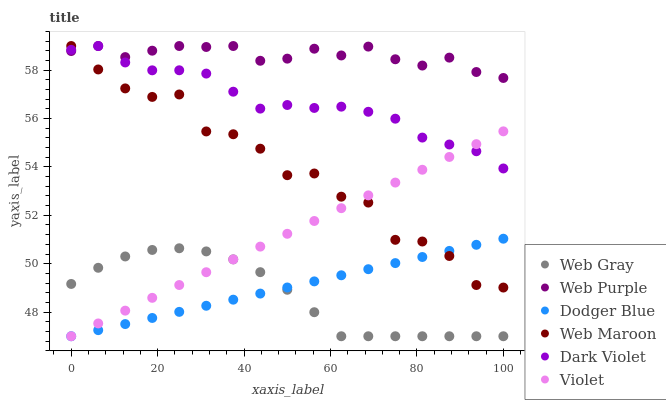Does Web Gray have the minimum area under the curve?
Answer yes or no. Yes. Does Web Purple have the maximum area under the curve?
Answer yes or no. Yes. Does Web Maroon have the minimum area under the curve?
Answer yes or no. No. Does Web Maroon have the maximum area under the curve?
Answer yes or no. No. Is Dodger Blue the smoothest?
Answer yes or no. Yes. Is Web Maroon the roughest?
Answer yes or no. Yes. Is Dark Violet the smoothest?
Answer yes or no. No. Is Dark Violet the roughest?
Answer yes or no. No. Does Web Gray have the lowest value?
Answer yes or no. Yes. Does Web Maroon have the lowest value?
Answer yes or no. No. Does Web Purple have the highest value?
Answer yes or no. Yes. Does Dodger Blue have the highest value?
Answer yes or no. No. Is Web Gray less than Web Maroon?
Answer yes or no. Yes. Is Web Purple greater than Dodger Blue?
Answer yes or no. Yes. Does Dark Violet intersect Web Purple?
Answer yes or no. Yes. Is Dark Violet less than Web Purple?
Answer yes or no. No. Is Dark Violet greater than Web Purple?
Answer yes or no. No. Does Web Gray intersect Web Maroon?
Answer yes or no. No. 